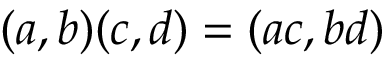<formula> <loc_0><loc_0><loc_500><loc_500>( a , b ) ( c , d ) = ( a c , b d )</formula> 